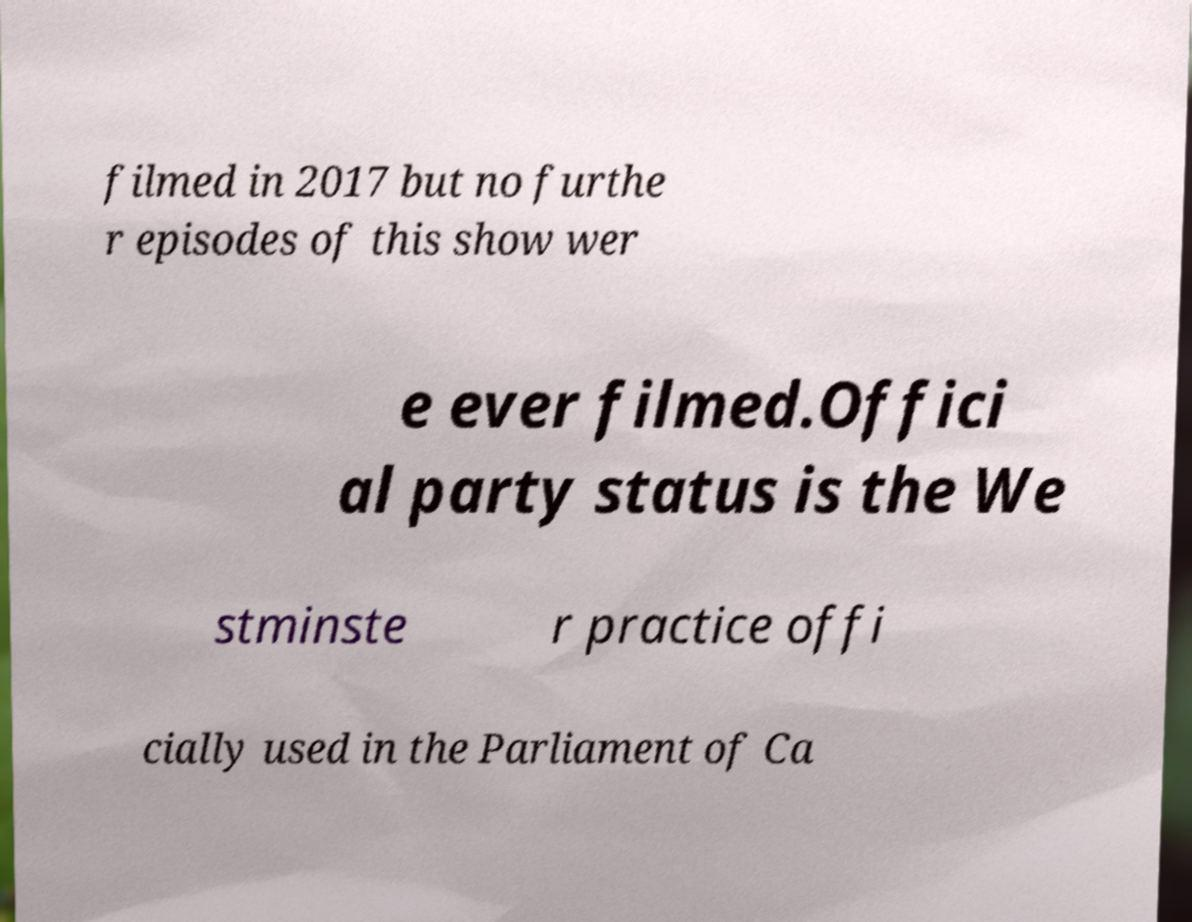Could you extract and type out the text from this image? filmed in 2017 but no furthe r episodes of this show wer e ever filmed.Offici al party status is the We stminste r practice offi cially used in the Parliament of Ca 